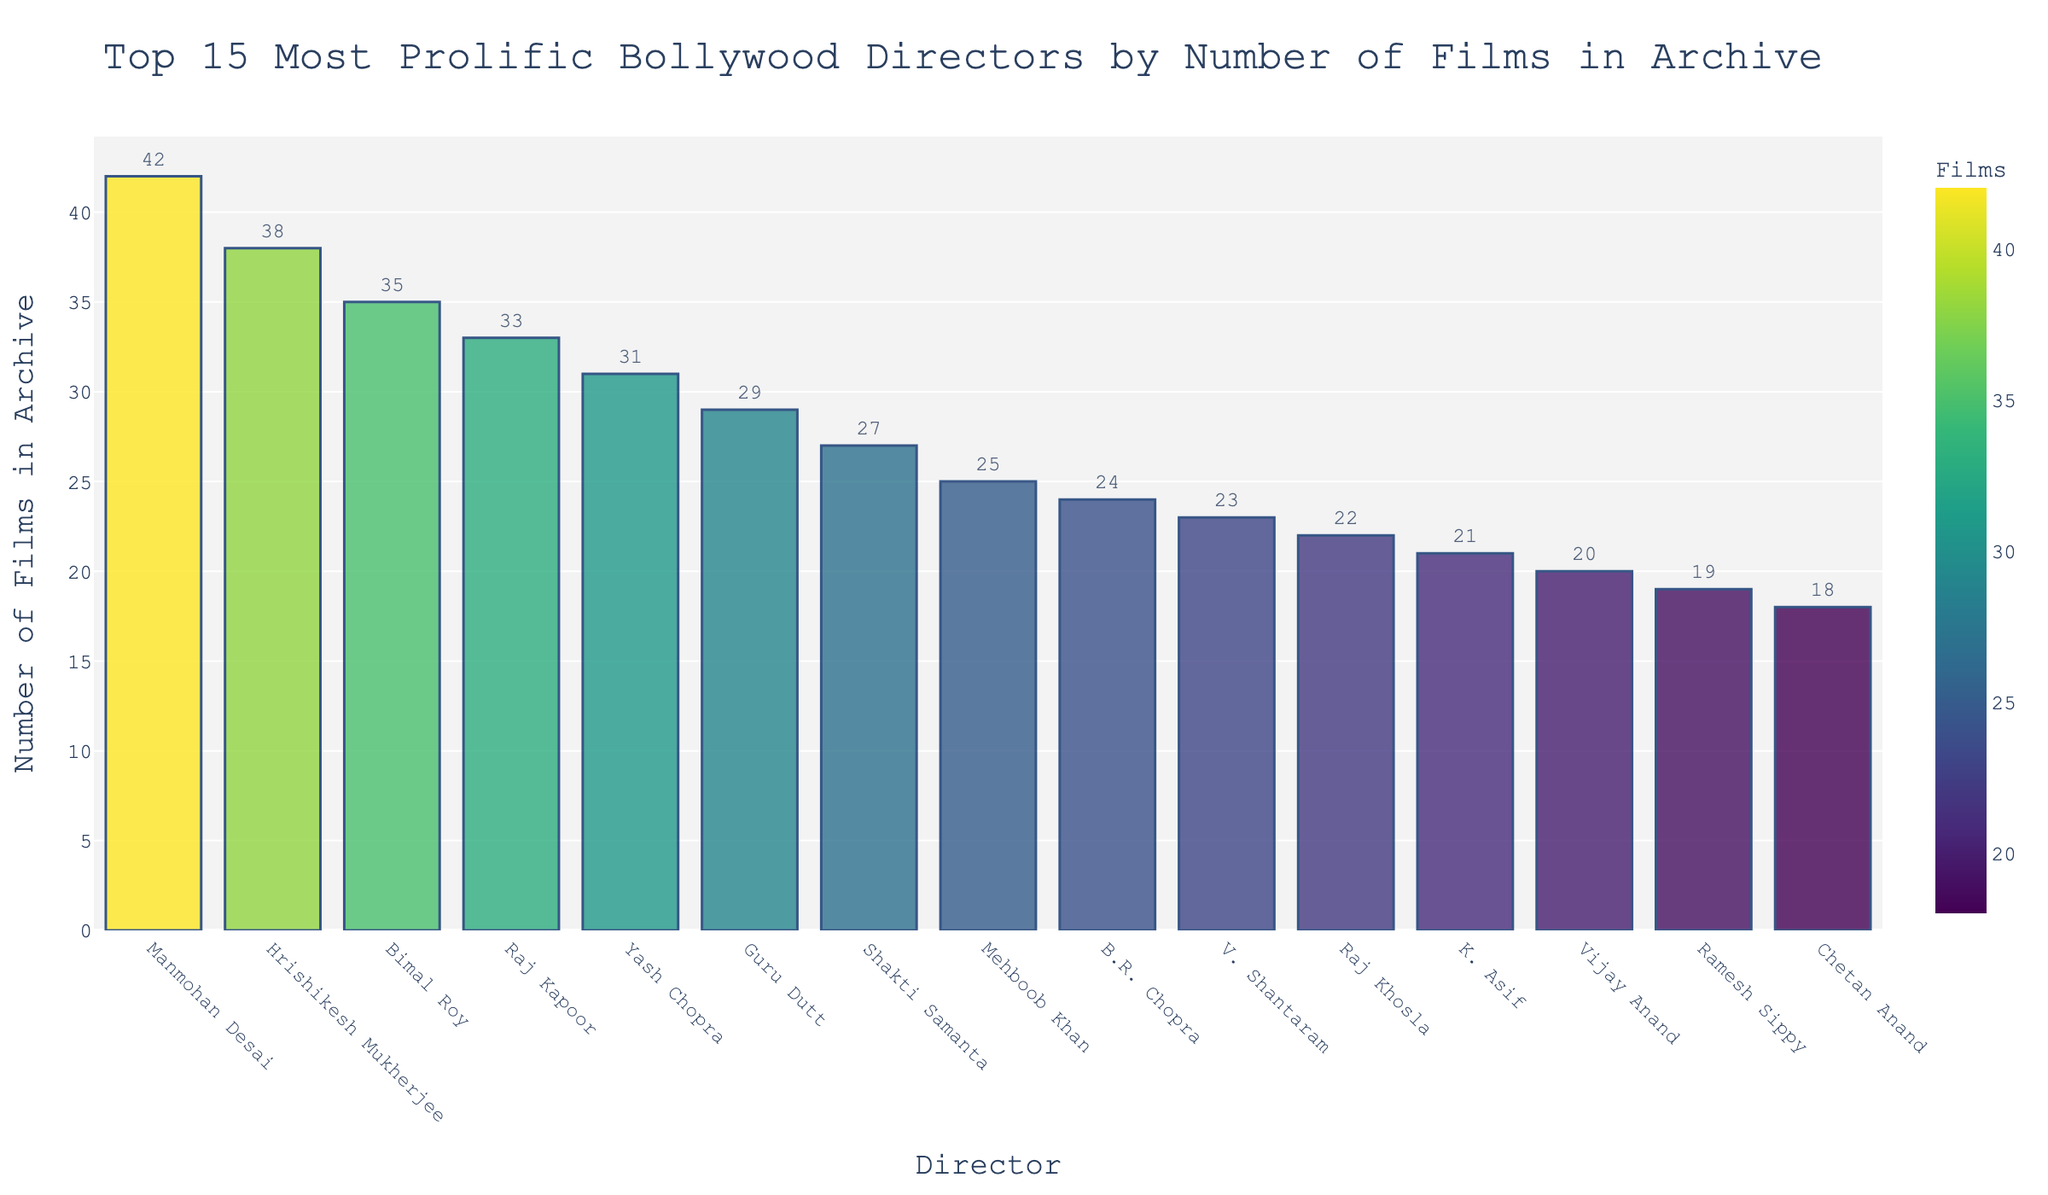Who is the most prolific Bollywood director in the archive? Manmohan Desai has the highest number of films stored in the archive at 42, as seen by the tallest bar in the chart.
Answer: Manmohan Desai What is the range of films directed by the top 10 directors? The top 10 directors have a range between 23 films by V. Shantaram and 42 films by Manmohan Desai. The range is calculated as 42 - 23.
Answer: 19 How many films did Hrishikesh Mukherjee and Bimal Roy direct in total? Adding the number of films directed by Hrishikesh Mukherjee (38) and Bimal Roy (35), we get 38 + 35 = 73 films.
Answer: 73 Which director has fewer films in the archive: Raj Kapoor or Yash Chopra? Raj Kapoor has 33 films, while Yash Chopra has 31 films. Comparing the two, Yash Chopra has fewer films.
Answer: Yash Chopra How many more films did Guru Dutt direct compared to Mehboob Khan? Guru Dutt directed 29 films, and Mehboob Khan directed 25 films. The difference is 29 - 25 = 4 films.
Answer: 4 What’s the average number of films directed by the top 5 directors? Summing the number of films directed by the top 5 directors: 42 (Manmohan Desai) + 38 (Hrishikesh Mukherjee) + 35 (Bimal Roy) + 33 (Raj Kapoor) + 31 (Yash Chopra) = 179. Dividing 179 by 5 gives an average of 35.8.
Answer: 35.8 Is the number of films by Shakti Samanta closer to Guru Dutt or Bimal Roy? Shakti Samanta directed 27 films. Guru Dutt directed 29 films (difference: 2), and Bimal Roy directed 35 films (difference: 8). The number of films by Shakti Samanta is closer to Guru Dutt.
Answer: Guru Dutt Which director is just above K. Asif in terms of the number of films? K. Asif has directed 21 films. Looking at the next higher bar, Raj Khosla has 22 films.
Answer: Raj Khosla What color represents the directors with the least number of films in the visual representation? The color representing the directors with fewer films in this Viridis scale would be closer to yellow/green.
Answer: Yellow/Green How many more films did Vijay Anand direct compared to Ramesh Sippy? Vijay Anand directed 20 films, Ramesh Sippy directed 19 films. The difference is 20 - 19 = 1 film.
Answer: 1 